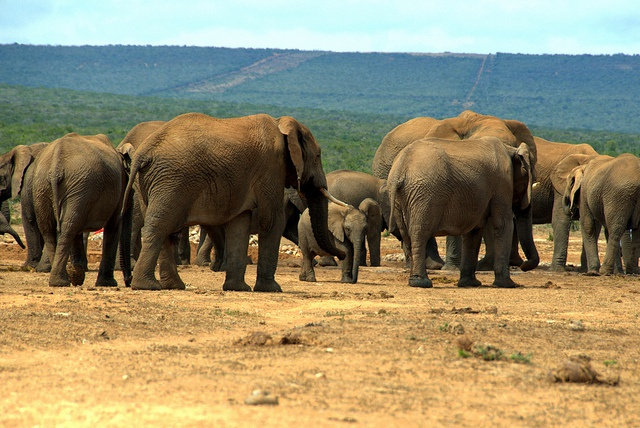Describe the objects in this image and their specific colors. I can see elephant in lightblue, black, and olive tones, elephant in lightblue, black, tan, and gray tones, elephant in lightblue, black, olive, tan, and gray tones, elephant in lightblue, black, olive, tan, and gray tones, and elephant in lightblue, tan, black, and olive tones in this image. 